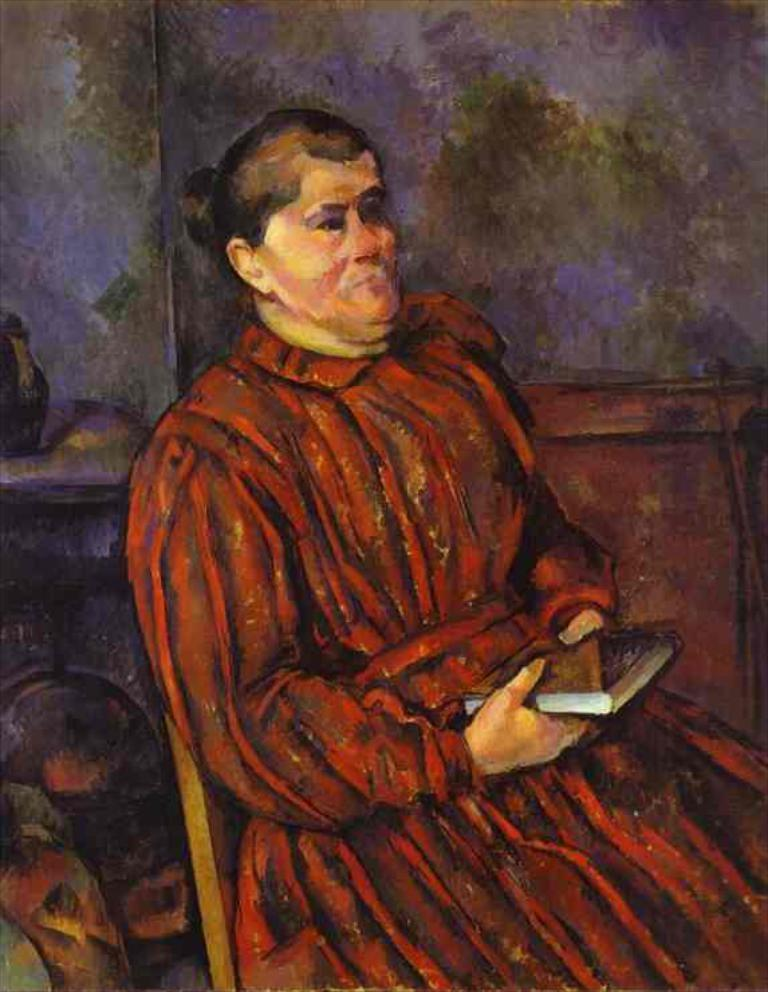What is the main subject of the image? There is a painting in the image. What is happening in the painting? The painting depicts a person sitting on a chair. What is the person in the painting holding? The person in the painting is holding a book. What can be seen behind the painting? There is a wall visible in the image. What type of water can be seen flowing through the painting? There is no water present in the painting; it depicts a person sitting on a chair and holding a book. 